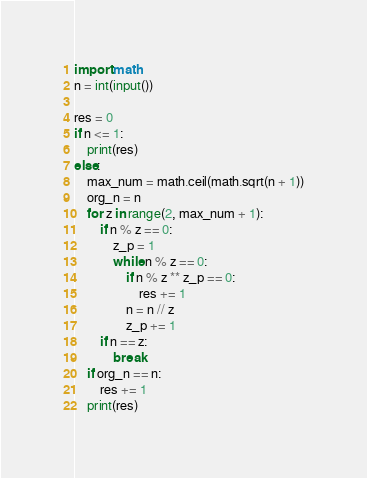Convert code to text. <code><loc_0><loc_0><loc_500><loc_500><_Python_>import math
n = int(input())

res = 0
if n <= 1:
	print(res)
else:
	max_num = math.ceil(math.sqrt(n + 1))
	org_n = n
	for z in range(2, max_num + 1):
		if n % z == 0:
			z_p = 1
			while n % z == 0:
				if n % z ** z_p == 0:
					res += 1
				n = n // z
				z_p += 1
		if n == z:
			break
	if org_n == n:
		res += 1
	print(res)</code> 